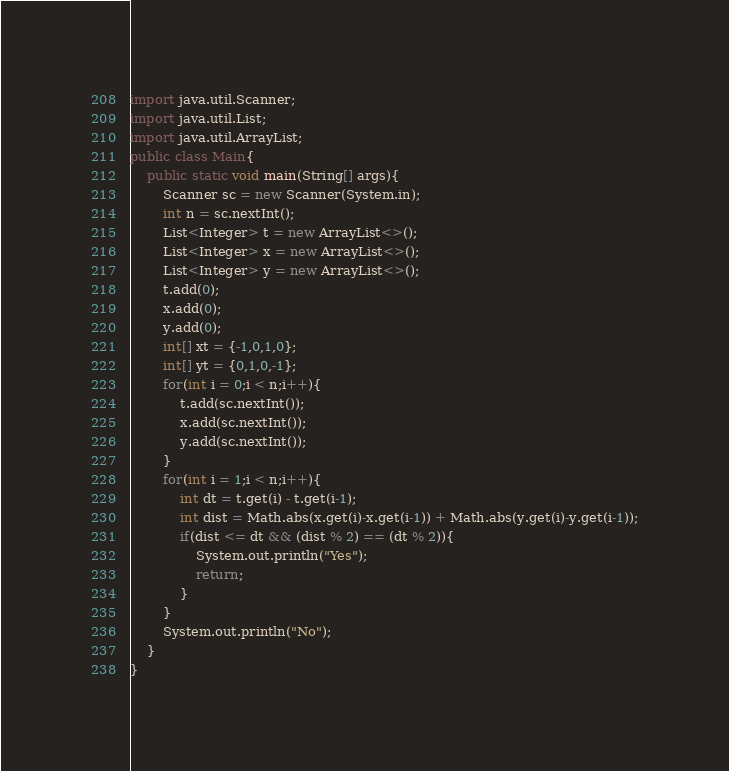Convert code to text. <code><loc_0><loc_0><loc_500><loc_500><_Java_>import java.util.Scanner;
import java.util.List;
import java.util.ArrayList;
public class Main{
    public static void main(String[] args){
        Scanner sc = new Scanner(System.in);
        int n = sc.nextInt();
        List<Integer> t = new ArrayList<>();
        List<Integer> x = new ArrayList<>();
        List<Integer> y = new ArrayList<>();
        t.add(0);
        x.add(0);
        y.add(0);
        int[] xt = {-1,0,1,0};
        int[] yt = {0,1,0,-1};
        for(int i = 0;i < n;i++){
            t.add(sc.nextInt());
            x.add(sc.nextInt());
            y.add(sc.nextInt());
        }
        for(int i = 1;i < n;i++){
            int dt = t.get(i) - t.get(i-1);
            int dist = Math.abs(x.get(i)-x.get(i-1)) + Math.abs(y.get(i)-y.get(i-1));
            if(dist <= dt && (dist % 2) == (dt % 2)){
                System.out.println("Yes");
                return;
            }
        }
        System.out.println("No");
    }
}
</code> 